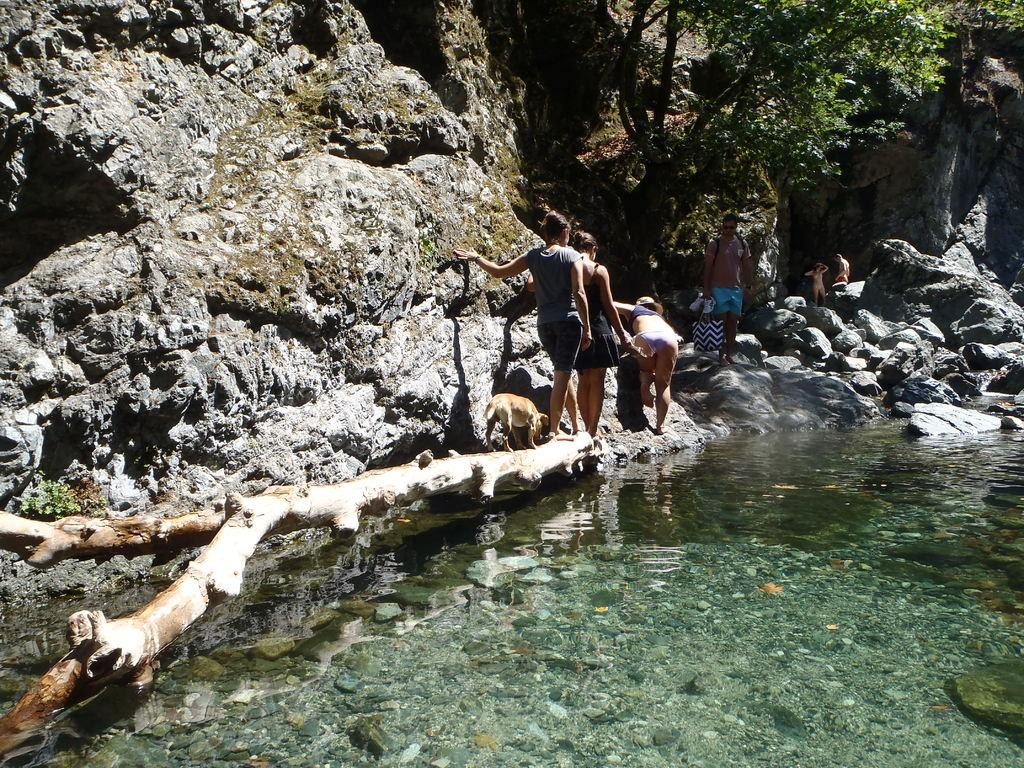What is visible in the image? There is water, people, an animal, and a tree visible in the image. Can you describe the animal in the image? Unfortunately, the facts provided do not give enough information to describe the animal in the image. What type of environment is depicted in the image? The presence of water, a tree, and people suggests that the image depicts a natural environment. What type of silk is being used to make the trail in the image? There is no trail or silk present in the image. What is the minister doing in the image? There is no minister present in the image. 